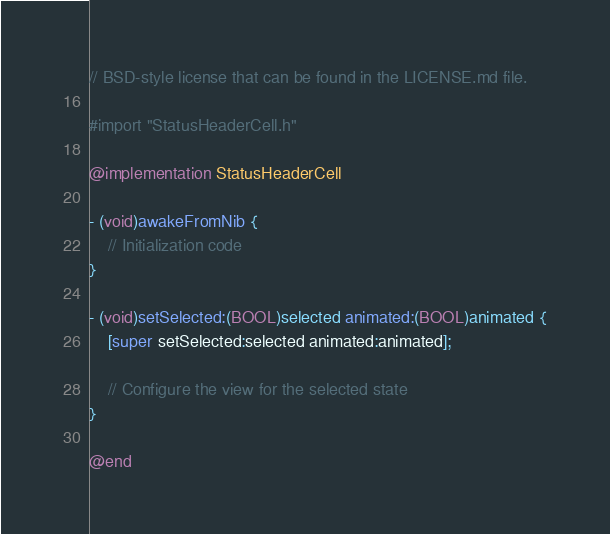Convert code to text. <code><loc_0><loc_0><loc_500><loc_500><_ObjectiveC_>// BSD-style license that can be found in the LICENSE.md file.

#import "StatusHeaderCell.h"

@implementation StatusHeaderCell

- (void)awakeFromNib {
    // Initialization code
}

- (void)setSelected:(BOOL)selected animated:(BOOL)animated {
    [super setSelected:selected animated:animated];

    // Configure the view for the selected state
}

@end
</code> 